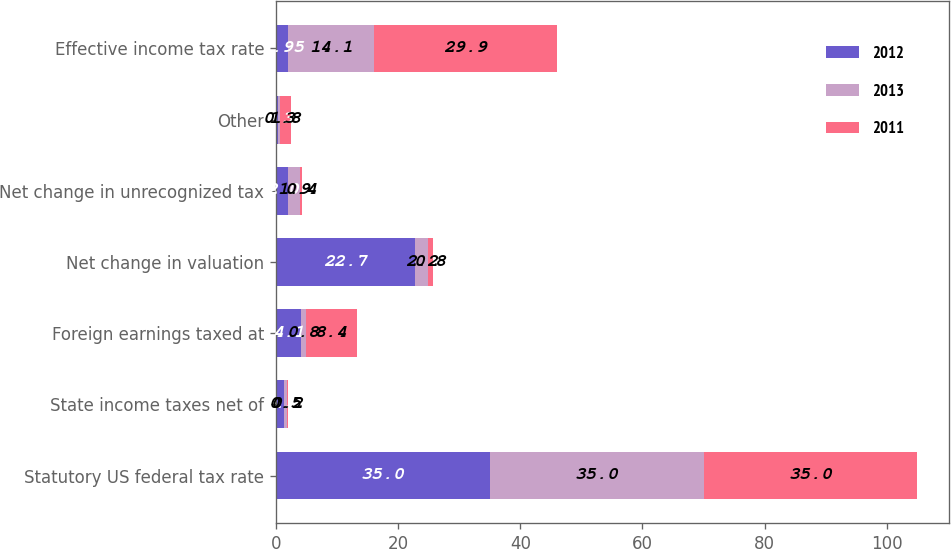Convert chart. <chart><loc_0><loc_0><loc_500><loc_500><stacked_bar_chart><ecel><fcel>Statutory US federal tax rate<fcel>State income taxes net of<fcel>Foreign earnings taxed at<fcel>Net change in valuation<fcel>Net change in unrecognized tax<fcel>Other<fcel>Effective income tax rate<nl><fcel>2012<fcel>35<fcel>1.3<fcel>4.1<fcel>22.7<fcel>2<fcel>0.3<fcel>1.95<nl><fcel>2013<fcel>35<fcel>0.5<fcel>0.8<fcel>2.2<fcel>1.9<fcel>0.3<fcel>14.1<nl><fcel>2011<fcel>35<fcel>0.2<fcel>8.4<fcel>0.8<fcel>0.4<fcel>1.8<fcel>29.9<nl></chart> 